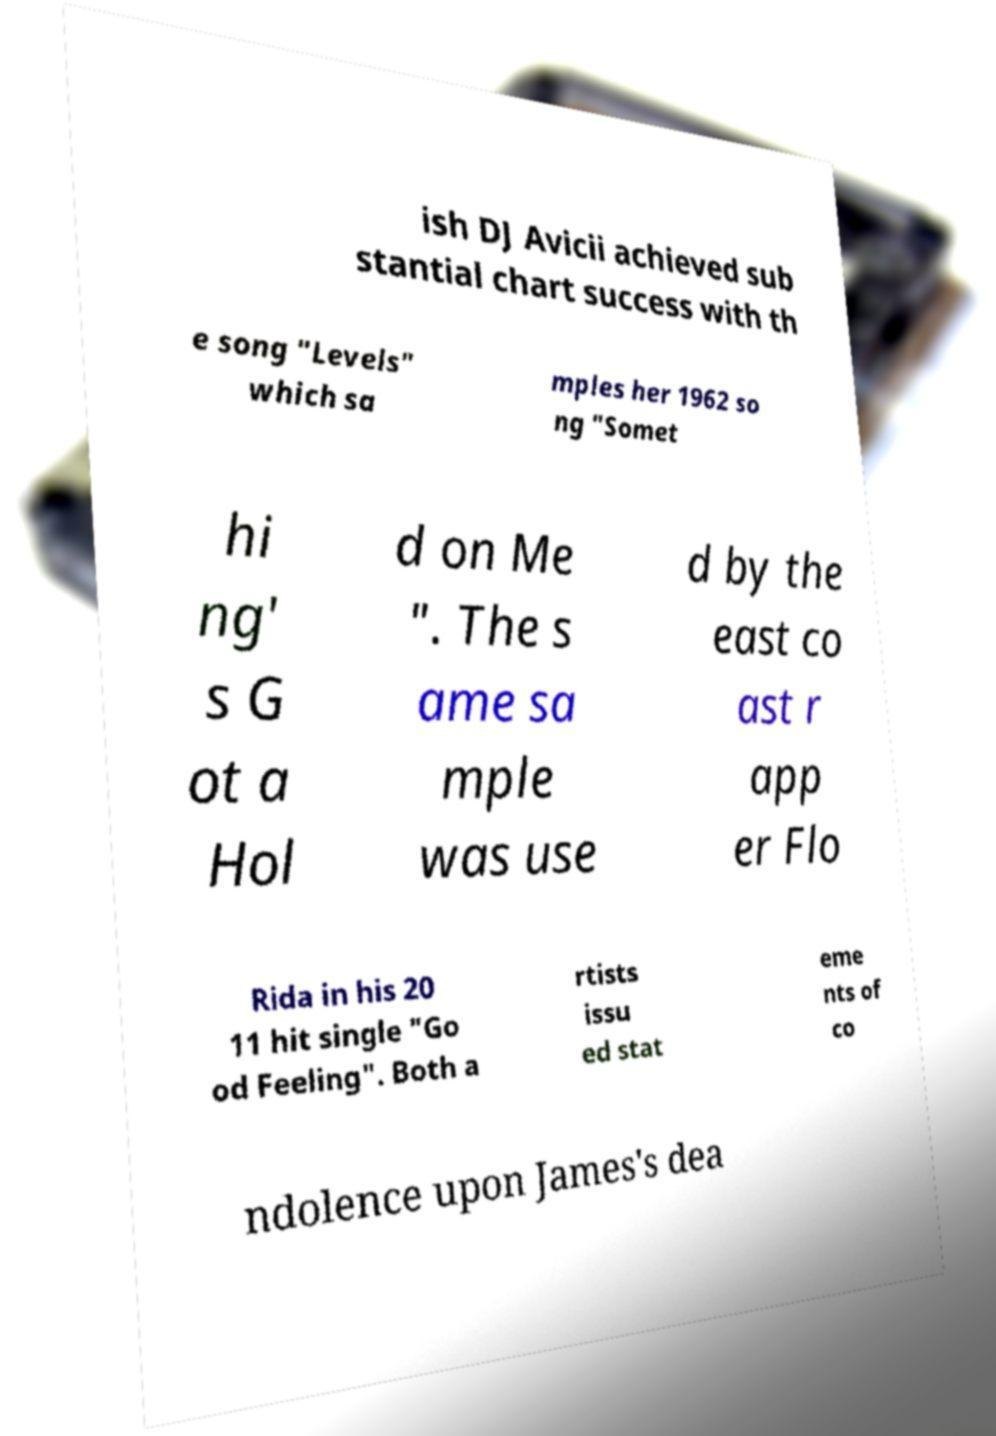What messages or text are displayed in this image? I need them in a readable, typed format. ish DJ Avicii achieved sub stantial chart success with th e song "Levels" which sa mples her 1962 so ng "Somet hi ng' s G ot a Hol d on Me ". The s ame sa mple was use d by the east co ast r app er Flo Rida in his 20 11 hit single "Go od Feeling". Both a rtists issu ed stat eme nts of co ndolence upon James's dea 